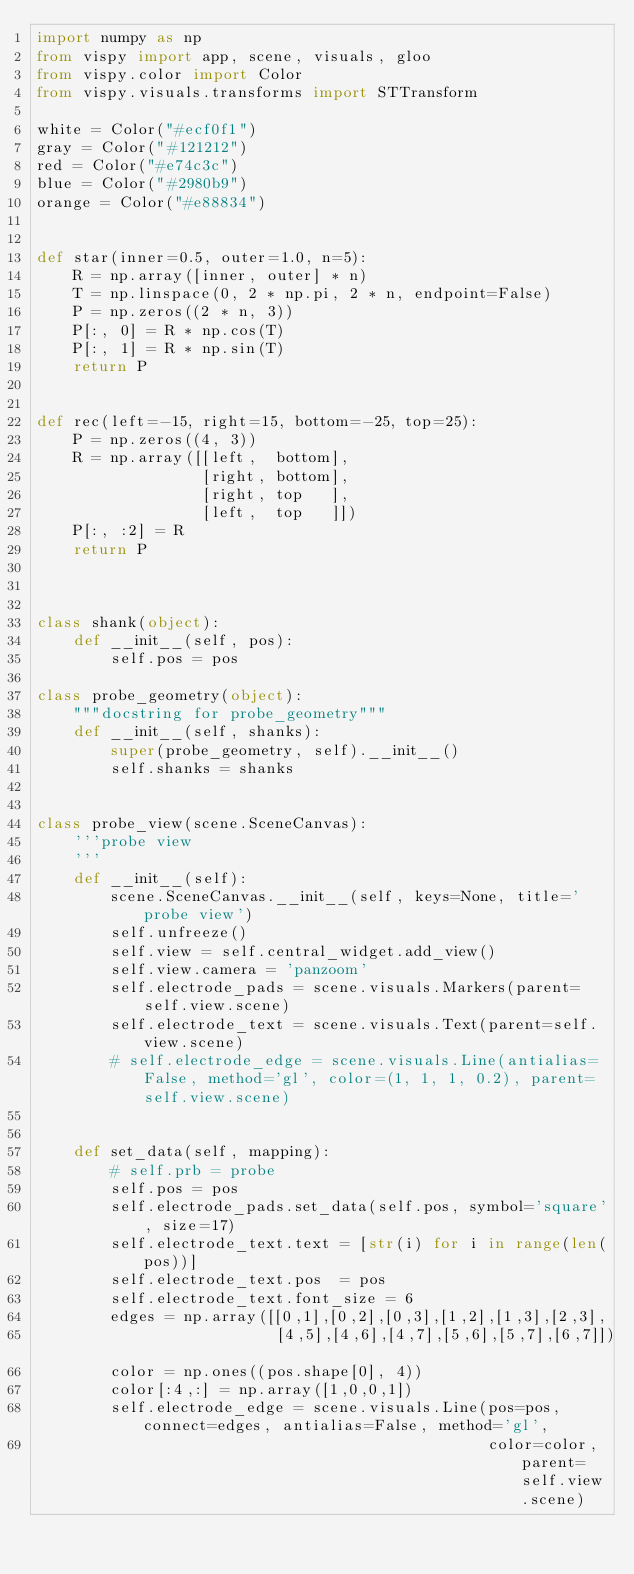Convert code to text. <code><loc_0><loc_0><loc_500><loc_500><_Python_>import numpy as np
from vispy import app, scene, visuals, gloo
from vispy.color import Color
from vispy.visuals.transforms import STTransform

white = Color("#ecf0f1")
gray = Color("#121212")
red = Color("#e74c3c")
blue = Color("#2980b9")
orange = Color("#e88834")


def star(inner=0.5, outer=1.0, n=5):
    R = np.array([inner, outer] * n)
    T = np.linspace(0, 2 * np.pi, 2 * n, endpoint=False)
    P = np.zeros((2 * n, 3))
    P[:, 0] = R * np.cos(T)
    P[:, 1] = R * np.sin(T)
    return P


def rec(left=-15, right=15, bottom=-25, top=25):
    P = np.zeros((4, 3))
    R = np.array([[left,  bottom],
                  [right, bottom],
                  [right, top   ],
                  [left,  top   ]])
    P[:, :2] = R
    return P



class shank(object):
    def __init__(self, pos):
        self.pos = pos

class probe_geometry(object):
    """docstring for probe_geometry"""
    def __init__(self, shanks):
        super(probe_geometry, self).__init__()
        self.shanks = shanks


class probe_view(scene.SceneCanvas):
    '''probe view
    '''
    def __init__(self):
        scene.SceneCanvas.__init__(self, keys=None, title='probe view')
        self.unfreeze()
        self.view = self.central_widget.add_view()
        self.view.camera = 'panzoom'
        self.electrode_pads = scene.visuals.Markers(parent=self.view.scene)
        self.electrode_text = scene.visuals.Text(parent=self.view.scene)
        # self.electrode_edge = scene.visuals.Line(antialias=False, method='gl', color=(1, 1, 1, 0.2), parent=self.view.scene)
        

    def set_data(self, mapping):
        # self.prb = probe
        self.pos = pos
        self.electrode_pads.set_data(self.pos, symbol='square', size=17)
        self.electrode_text.text = [str(i) for i in range(len(pos))] 
        self.electrode_text.pos  = pos
        self.electrode_text.font_size = 6
        edges = np.array([[0,1],[0,2],[0,3],[1,2],[1,3],[2,3],
                          [4,5],[4,6],[4,7],[5,6],[5,7],[6,7]])
        color = np.ones((pos.shape[0], 4))
        color[:4,:] = np.array([1,0,0,1])
        self.electrode_edge = scene.visuals.Line(pos=pos, connect=edges, antialias=False, method='gl',
                                                 color=color, parent=self.view.scene)
</code> 